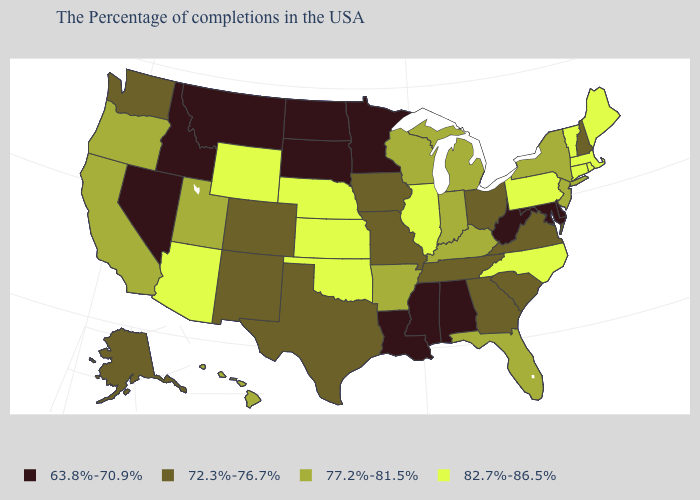What is the value of West Virginia?
Answer briefly. 63.8%-70.9%. Name the states that have a value in the range 72.3%-76.7%?
Quick response, please. New Hampshire, Virginia, South Carolina, Ohio, Georgia, Tennessee, Missouri, Iowa, Texas, Colorado, New Mexico, Washington, Alaska. Name the states that have a value in the range 72.3%-76.7%?
Answer briefly. New Hampshire, Virginia, South Carolina, Ohio, Georgia, Tennessee, Missouri, Iowa, Texas, Colorado, New Mexico, Washington, Alaska. What is the lowest value in the West?
Give a very brief answer. 63.8%-70.9%. Which states have the highest value in the USA?
Give a very brief answer. Maine, Massachusetts, Rhode Island, Vermont, Connecticut, Pennsylvania, North Carolina, Illinois, Kansas, Nebraska, Oklahoma, Wyoming, Arizona. Does West Virginia have the lowest value in the South?
Write a very short answer. Yes. Which states have the lowest value in the USA?
Short answer required. Delaware, Maryland, West Virginia, Alabama, Mississippi, Louisiana, Minnesota, South Dakota, North Dakota, Montana, Idaho, Nevada. How many symbols are there in the legend?
Short answer required. 4. Among the states that border Arizona , does Nevada have the lowest value?
Answer briefly. Yes. How many symbols are there in the legend?
Give a very brief answer. 4. What is the value of Maryland?
Write a very short answer. 63.8%-70.9%. Is the legend a continuous bar?
Keep it brief. No. Is the legend a continuous bar?
Short answer required. No. What is the lowest value in the USA?
Be succinct. 63.8%-70.9%. 